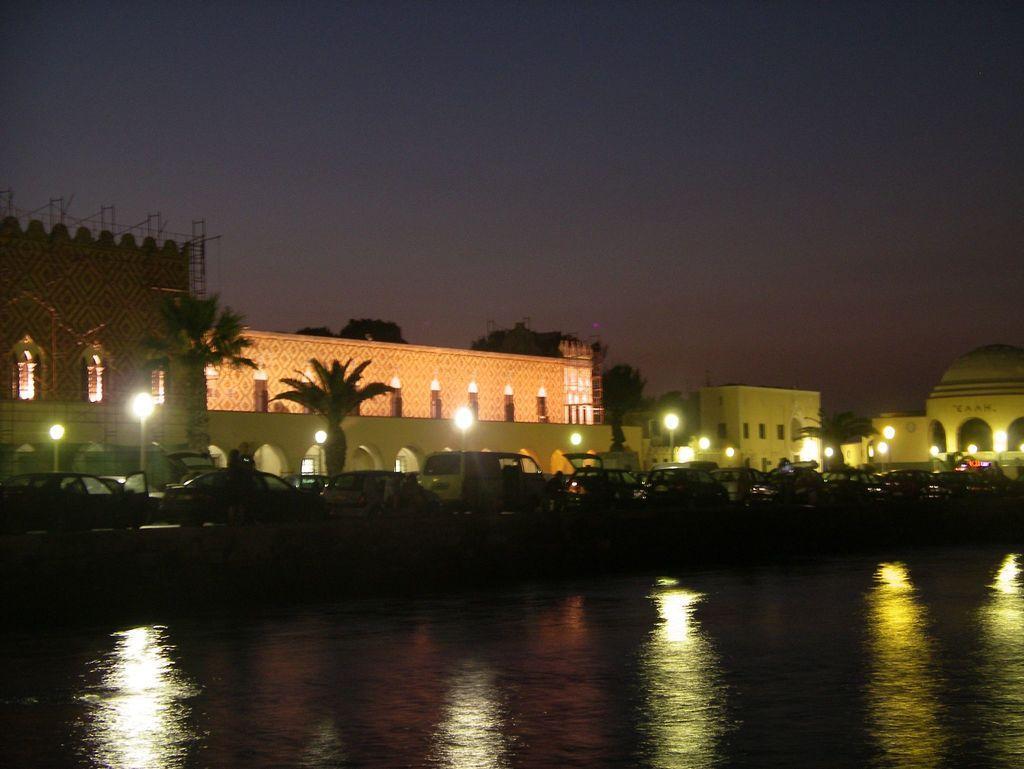How would you summarize this image in a sentence or two? In this image I can see water, few vehicles on the road, light poles, trees in green color, a building in white color and the sky is in blue color. 